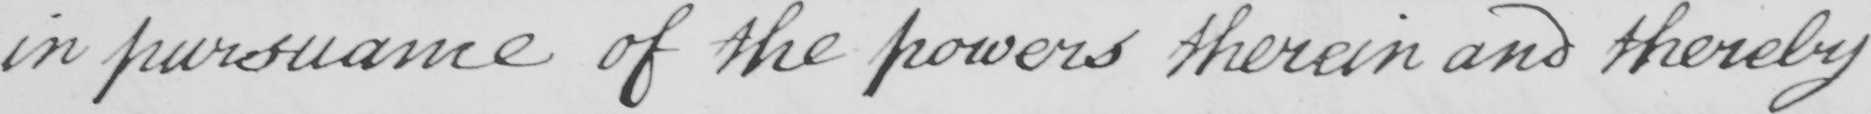Transcribe the text shown in this historical manuscript line. in pursuance of the powers therein and thereby 